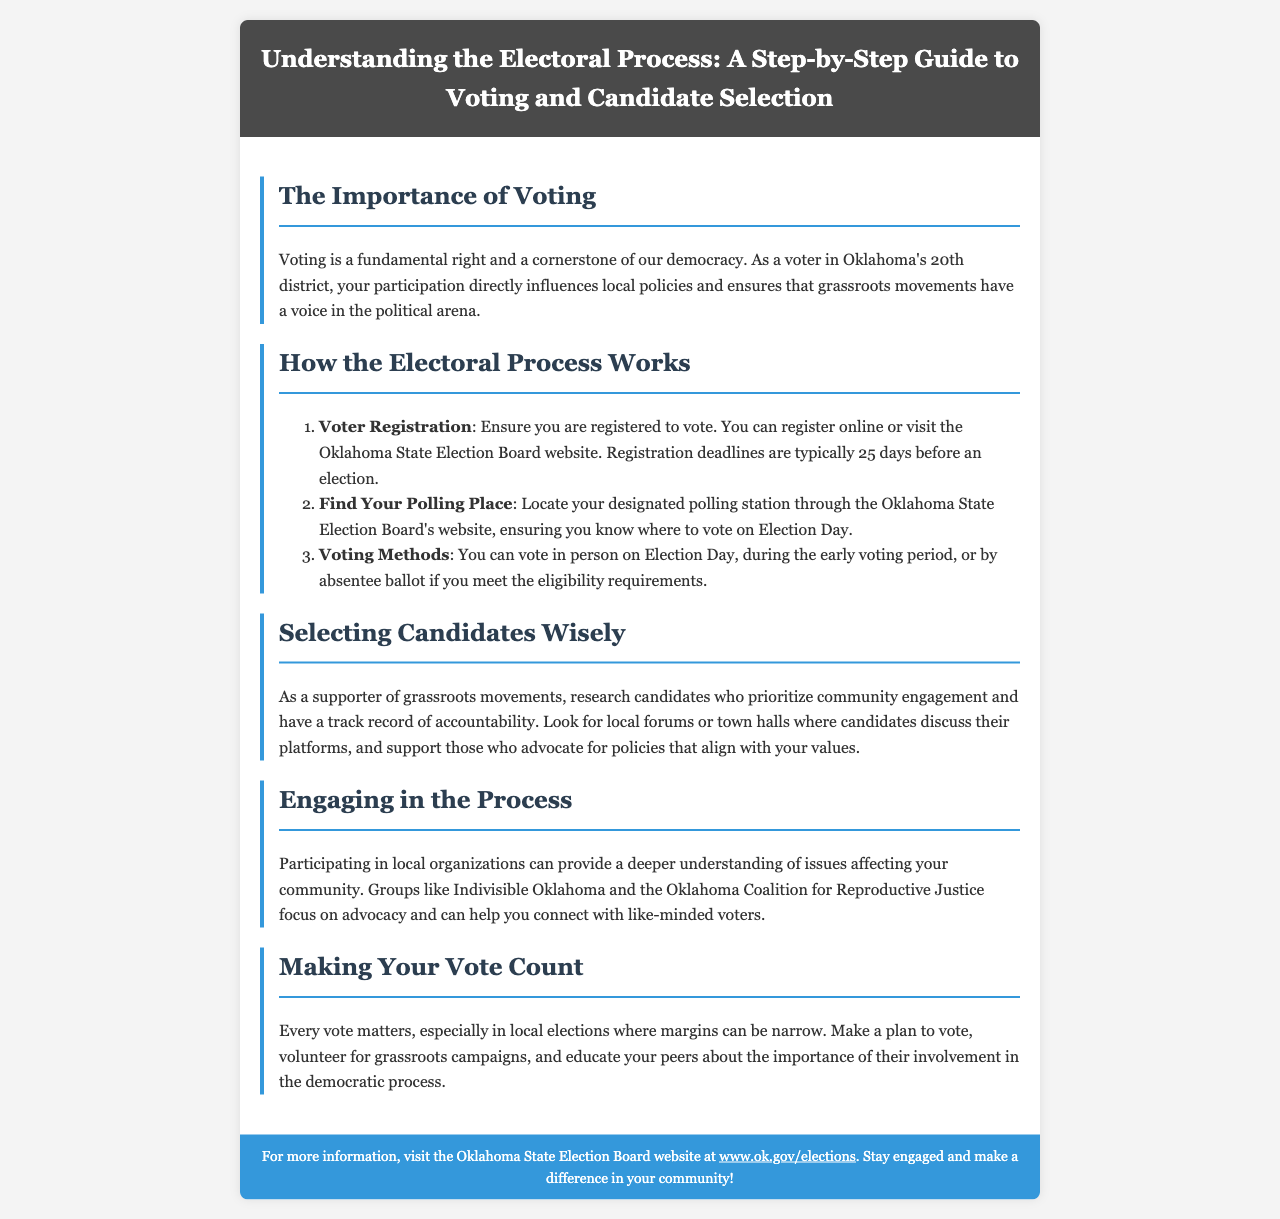What is the main theme of the brochure? The main theme is about the electoral process, guiding voters on voting and candidate selection.
Answer: electoral process How many days before an election must you register to vote? The document states that registration deadlines are typically 25 days before an election.
Answer: 25 days What is the first step in the electoral process outlined? The first step is to ensure you are registered to vote.
Answer: Voter Registration What should voters look for when selecting candidates? Voters should research candidates who prioritize community engagement and have a track record of accountability.
Answer: community engagement What groups does the brochure mention for community engagement? The brochure specifically mentions Indivisible Oklahoma and the Oklahoma Coalition for Reproductive Justice.
Answer: Indivisible Oklahoma, Oklahoma Coalition for Reproductive Justice What is emphasized about local elections? The brochure emphasizes that every vote matters, especially in local elections where margins can be narrow.
Answer: every vote matters How can voters educate their peers about voting? The document suggests that voters can educate their peers by discussing the importance of their involvement in the democratic process.
Answer: discussing importance What does the footer encourage readers to do? The footer encourages readers to stay engaged and make a difference in their community.
Answer: stay engaged and make a difference 